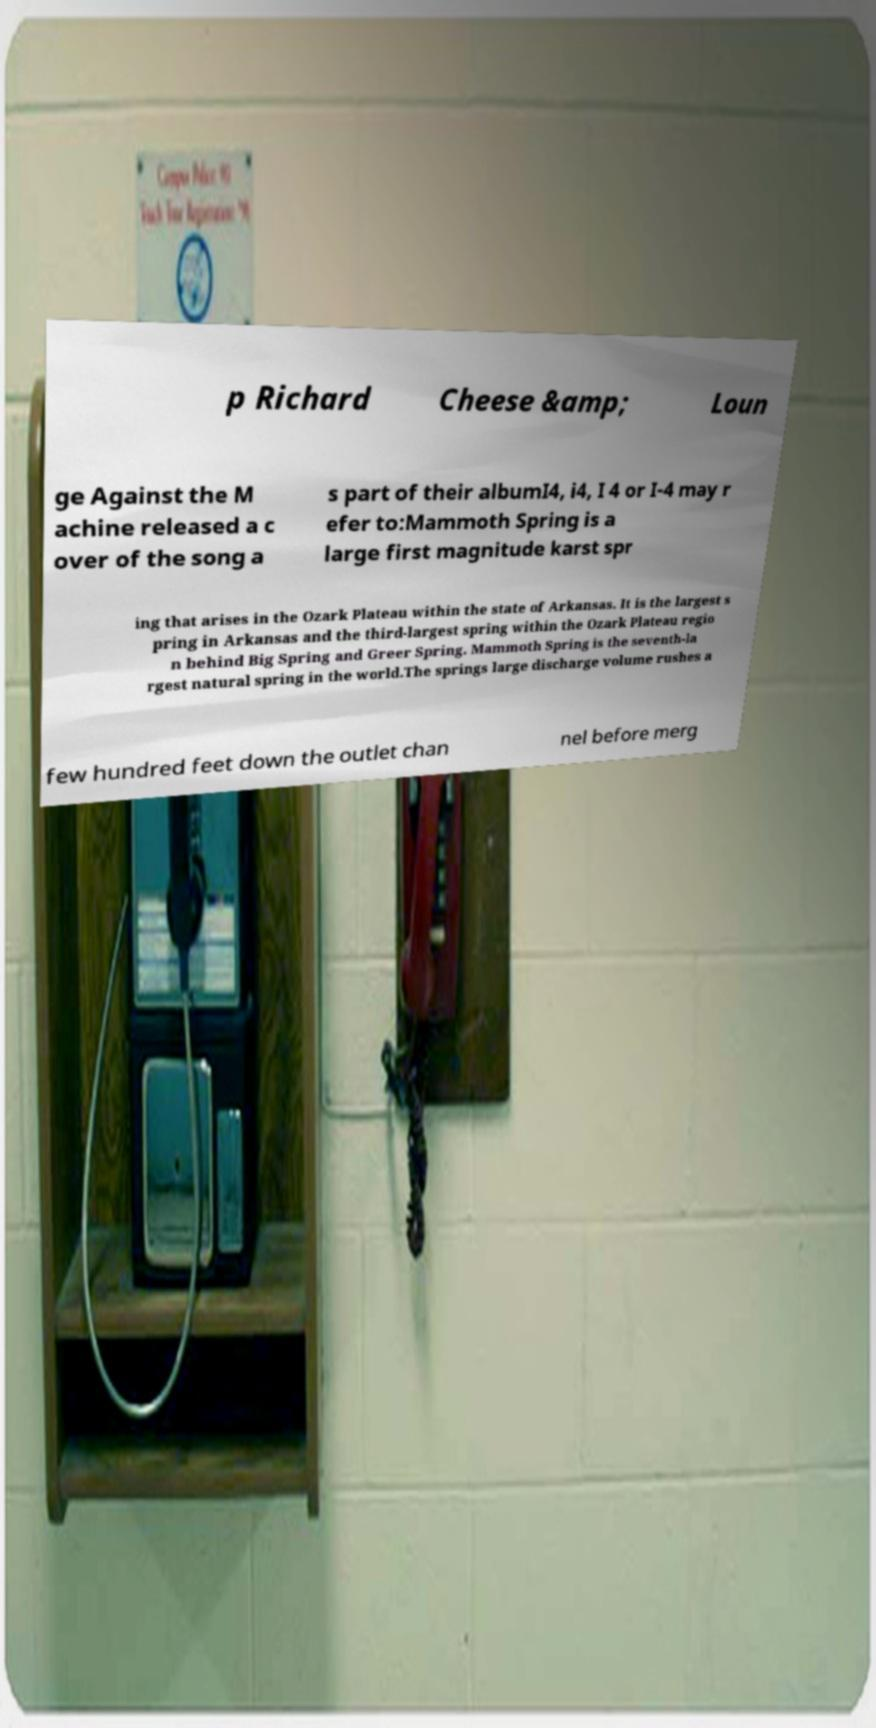Could you extract and type out the text from this image? p Richard Cheese &amp; Loun ge Against the M achine released a c over of the song a s part of their albumI4, i4, I 4 or I-4 may r efer to:Mammoth Spring is a large first magnitude karst spr ing that arises in the Ozark Plateau within the state of Arkansas. It is the largest s pring in Arkansas and the third-largest spring within the Ozark Plateau regio n behind Big Spring and Greer Spring. Mammoth Spring is the seventh-la rgest natural spring in the world.The springs large discharge volume rushes a few hundred feet down the outlet chan nel before merg 